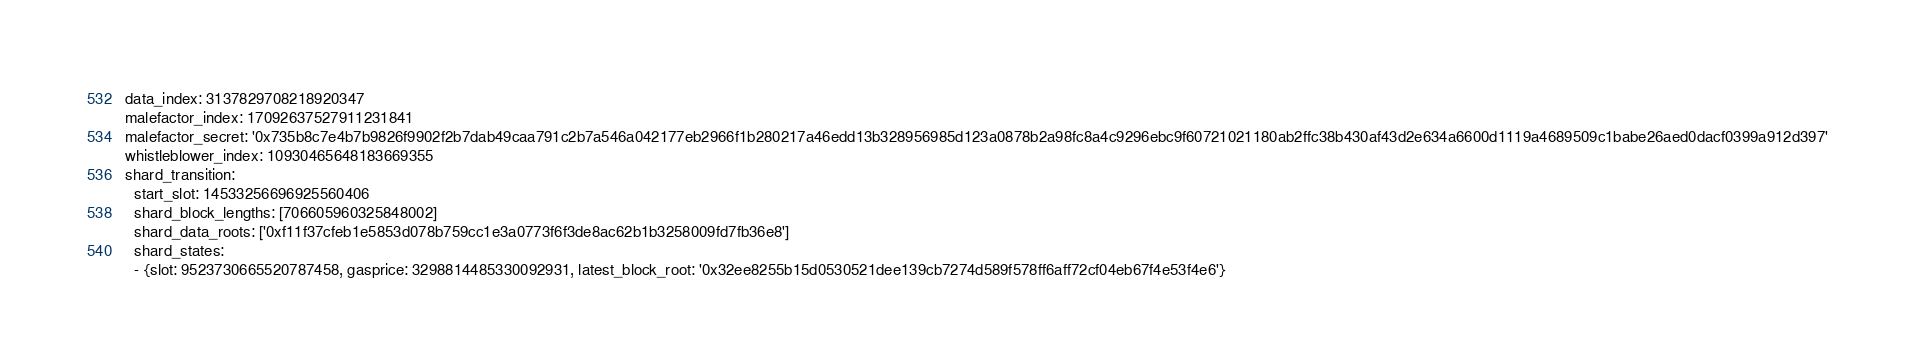<code> <loc_0><loc_0><loc_500><loc_500><_YAML_>data_index: 3137829708218920347
malefactor_index: 17092637527911231841
malefactor_secret: '0x735b8c7e4b7b9826f9902f2b7dab49caa791c2b7a546a042177eb2966f1b280217a46edd13b328956985d123a0878b2a98fc8a4c9296ebc9f60721021180ab2ffc38b430af43d2e634a6600d1119a4689509c1babe26aed0dacf0399a912d397'
whistleblower_index: 10930465648183669355
shard_transition:
  start_slot: 14533256696925560406
  shard_block_lengths: [706605960325848002]
  shard_data_roots: ['0xf11f37cfeb1e5853d078b759cc1e3a0773f6f3de8ac62b1b3258009fd7fb36e8']
  shard_states:
  - {slot: 9523730665520787458, gasprice: 3298814485330092931, latest_block_root: '0x32ee8255b15d0530521dee139cb7274d589f578ff6aff72cf04eb67f4e53f4e6'}</code> 